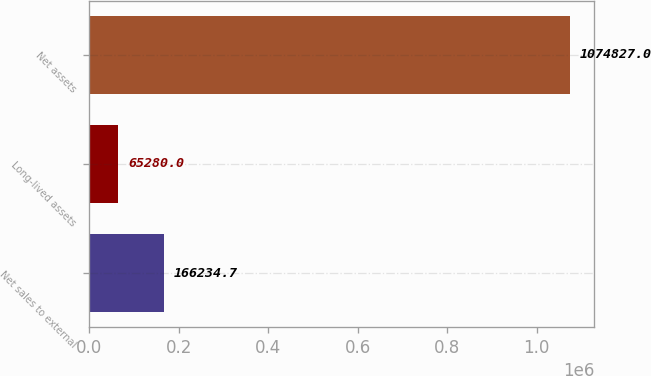Convert chart to OTSL. <chart><loc_0><loc_0><loc_500><loc_500><bar_chart><fcel>Net sales to external<fcel>Long-lived assets<fcel>Net assets<nl><fcel>166235<fcel>65280<fcel>1.07483e+06<nl></chart> 